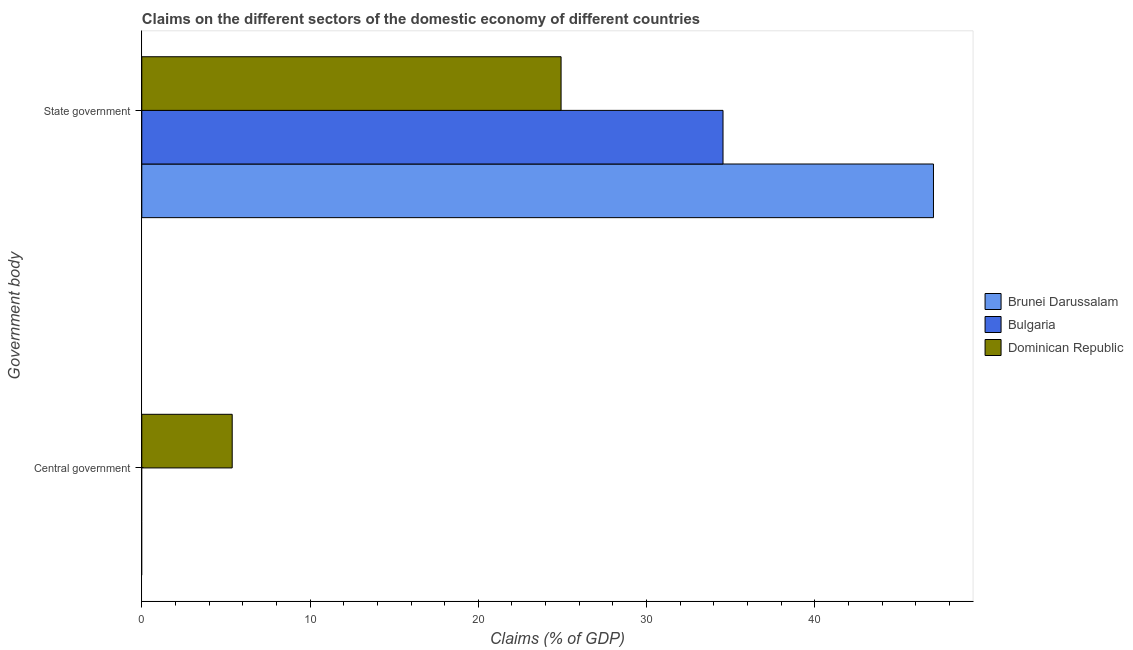How many different coloured bars are there?
Your answer should be compact. 3. How many bars are there on the 1st tick from the top?
Your response must be concise. 3. How many bars are there on the 1st tick from the bottom?
Your answer should be compact. 1. What is the label of the 1st group of bars from the top?
Provide a short and direct response. State government. Across all countries, what is the maximum claims on state government?
Offer a very short reply. 47.05. In which country was the claims on state government maximum?
Provide a succinct answer. Brunei Darussalam. What is the total claims on state government in the graph?
Provide a succinct answer. 106.51. What is the difference between the claims on state government in Brunei Darussalam and that in Dominican Republic?
Your answer should be compact. 22.13. What is the difference between the claims on state government in Dominican Republic and the claims on central government in Bulgaria?
Your answer should be compact. 24.92. What is the average claims on state government per country?
Provide a short and direct response. 35.5. What is the difference between the claims on central government and claims on state government in Dominican Republic?
Ensure brevity in your answer.  -19.55. What is the ratio of the claims on state government in Dominican Republic to that in Brunei Darussalam?
Provide a succinct answer. 0.53. Is the claims on state government in Brunei Darussalam less than that in Bulgaria?
Make the answer very short. No. How many bars are there?
Provide a succinct answer. 4. Are all the bars in the graph horizontal?
Give a very brief answer. Yes. How many countries are there in the graph?
Offer a very short reply. 3. What is the difference between two consecutive major ticks on the X-axis?
Your answer should be very brief. 10. Does the graph contain any zero values?
Your answer should be compact. Yes. Where does the legend appear in the graph?
Make the answer very short. Center right. What is the title of the graph?
Your response must be concise. Claims on the different sectors of the domestic economy of different countries. What is the label or title of the X-axis?
Offer a very short reply. Claims (% of GDP). What is the label or title of the Y-axis?
Provide a short and direct response. Government body. What is the Claims (% of GDP) in Dominican Republic in Central government?
Offer a terse response. 5.37. What is the Claims (% of GDP) of Brunei Darussalam in State government?
Offer a terse response. 47.05. What is the Claims (% of GDP) of Bulgaria in State government?
Ensure brevity in your answer.  34.54. What is the Claims (% of GDP) of Dominican Republic in State government?
Your answer should be compact. 24.92. Across all Government body, what is the maximum Claims (% of GDP) of Brunei Darussalam?
Your response must be concise. 47.05. Across all Government body, what is the maximum Claims (% of GDP) of Bulgaria?
Provide a succinct answer. 34.54. Across all Government body, what is the maximum Claims (% of GDP) in Dominican Republic?
Provide a short and direct response. 24.92. Across all Government body, what is the minimum Claims (% of GDP) in Brunei Darussalam?
Keep it short and to the point. 0. Across all Government body, what is the minimum Claims (% of GDP) in Dominican Republic?
Ensure brevity in your answer.  5.37. What is the total Claims (% of GDP) of Brunei Darussalam in the graph?
Give a very brief answer. 47.05. What is the total Claims (% of GDP) in Bulgaria in the graph?
Your answer should be very brief. 34.54. What is the total Claims (% of GDP) of Dominican Republic in the graph?
Offer a very short reply. 30.29. What is the difference between the Claims (% of GDP) of Dominican Republic in Central government and that in State government?
Your response must be concise. -19.55. What is the average Claims (% of GDP) of Brunei Darussalam per Government body?
Offer a very short reply. 23.53. What is the average Claims (% of GDP) of Bulgaria per Government body?
Your answer should be very brief. 17.27. What is the average Claims (% of GDP) in Dominican Republic per Government body?
Ensure brevity in your answer.  15.15. What is the difference between the Claims (% of GDP) in Brunei Darussalam and Claims (% of GDP) in Bulgaria in State government?
Your answer should be compact. 12.51. What is the difference between the Claims (% of GDP) in Brunei Darussalam and Claims (% of GDP) in Dominican Republic in State government?
Make the answer very short. 22.13. What is the difference between the Claims (% of GDP) in Bulgaria and Claims (% of GDP) in Dominican Republic in State government?
Make the answer very short. 9.62. What is the ratio of the Claims (% of GDP) of Dominican Republic in Central government to that in State government?
Provide a short and direct response. 0.22. What is the difference between the highest and the second highest Claims (% of GDP) in Dominican Republic?
Provide a succinct answer. 19.55. What is the difference between the highest and the lowest Claims (% of GDP) of Brunei Darussalam?
Your answer should be very brief. 47.05. What is the difference between the highest and the lowest Claims (% of GDP) in Bulgaria?
Your answer should be compact. 34.54. What is the difference between the highest and the lowest Claims (% of GDP) in Dominican Republic?
Make the answer very short. 19.55. 